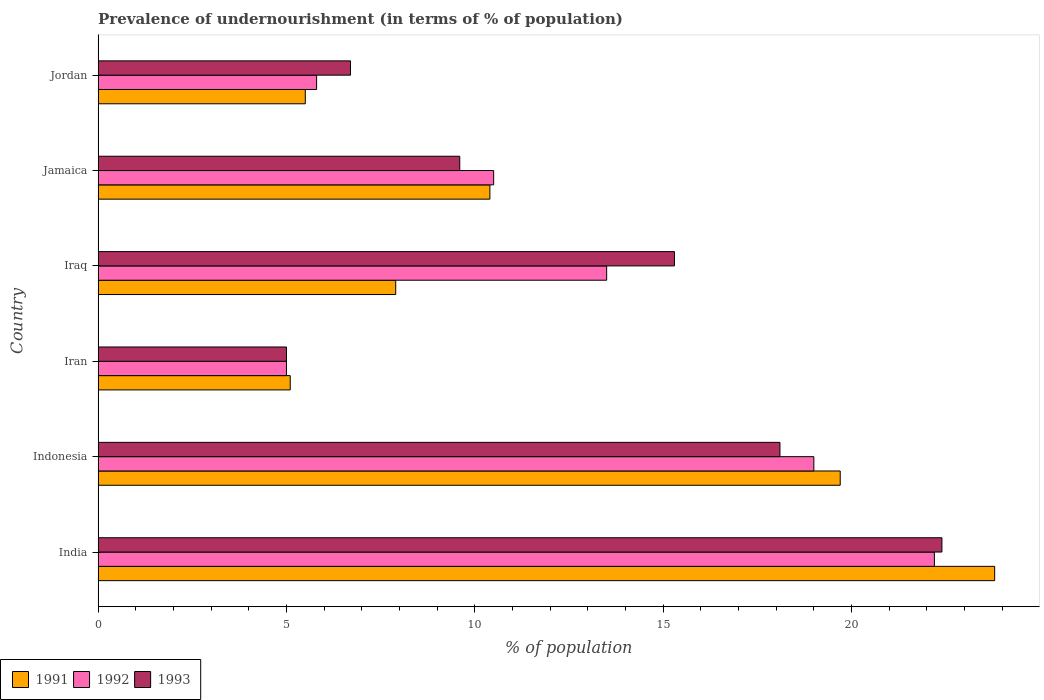How many different coloured bars are there?
Make the answer very short. 3. How many groups of bars are there?
Your response must be concise. 6. Are the number of bars per tick equal to the number of legend labels?
Your answer should be very brief. Yes. Are the number of bars on each tick of the Y-axis equal?
Make the answer very short. Yes. How many bars are there on the 6th tick from the top?
Your answer should be very brief. 3. How many bars are there on the 2nd tick from the bottom?
Provide a succinct answer. 3. What is the label of the 6th group of bars from the top?
Offer a terse response. India. In how many cases, is the number of bars for a given country not equal to the number of legend labels?
Your answer should be compact. 0. In which country was the percentage of undernourished population in 1993 maximum?
Your answer should be very brief. India. In which country was the percentage of undernourished population in 1993 minimum?
Make the answer very short. Iran. What is the total percentage of undernourished population in 1993 in the graph?
Offer a terse response. 77.1. What is the difference between the percentage of undernourished population in 1993 in Indonesia and that in Jamaica?
Provide a short and direct response. 8.5. What is the difference between the percentage of undernourished population in 1993 in Iraq and the percentage of undernourished population in 1991 in Iran?
Ensure brevity in your answer.  10.2. What is the average percentage of undernourished population in 1992 per country?
Your answer should be compact. 12.67. What is the difference between the percentage of undernourished population in 1991 and percentage of undernourished population in 1992 in Iraq?
Your answer should be compact. -5.6. What is the ratio of the percentage of undernourished population in 1993 in India to that in Iraq?
Your response must be concise. 1.46. What is the difference between the highest and the second highest percentage of undernourished population in 1991?
Your answer should be very brief. 4.1. What is the difference between the highest and the lowest percentage of undernourished population in 1991?
Give a very brief answer. 18.7. In how many countries, is the percentage of undernourished population in 1992 greater than the average percentage of undernourished population in 1992 taken over all countries?
Your answer should be compact. 3. What does the 1st bar from the top in India represents?
Your response must be concise. 1993. Are all the bars in the graph horizontal?
Offer a very short reply. Yes. How many countries are there in the graph?
Ensure brevity in your answer.  6. Are the values on the major ticks of X-axis written in scientific E-notation?
Give a very brief answer. No. Does the graph contain any zero values?
Make the answer very short. No. Where does the legend appear in the graph?
Offer a terse response. Bottom left. What is the title of the graph?
Keep it short and to the point. Prevalence of undernourishment (in terms of % of population). Does "2015" appear as one of the legend labels in the graph?
Provide a short and direct response. No. What is the label or title of the X-axis?
Ensure brevity in your answer.  % of population. What is the label or title of the Y-axis?
Keep it short and to the point. Country. What is the % of population in 1991 in India?
Provide a succinct answer. 23.8. What is the % of population in 1992 in India?
Make the answer very short. 22.2. What is the % of population of 1993 in India?
Make the answer very short. 22.4. What is the % of population of 1993 in Indonesia?
Offer a terse response. 18.1. What is the % of population of 1991 in Iraq?
Offer a terse response. 7.9. What is the % of population of 1992 in Iraq?
Offer a terse response. 13.5. What is the % of population of 1991 in Jamaica?
Ensure brevity in your answer.  10.4. What is the % of population of 1992 in Jamaica?
Provide a short and direct response. 10.5. What is the % of population in 1992 in Jordan?
Give a very brief answer. 5.8. What is the % of population of 1993 in Jordan?
Your answer should be very brief. 6.7. Across all countries, what is the maximum % of population in 1991?
Your answer should be compact. 23.8. Across all countries, what is the maximum % of population in 1993?
Your answer should be very brief. 22.4. Across all countries, what is the minimum % of population in 1991?
Provide a succinct answer. 5.1. What is the total % of population in 1991 in the graph?
Keep it short and to the point. 72.4. What is the total % of population in 1992 in the graph?
Your answer should be very brief. 76. What is the total % of population of 1993 in the graph?
Offer a terse response. 77.1. What is the difference between the % of population in 1991 in India and that in Indonesia?
Offer a very short reply. 4.1. What is the difference between the % of population of 1992 in India and that in Iran?
Keep it short and to the point. 17.2. What is the difference between the % of population of 1991 in Indonesia and that in Iraq?
Offer a terse response. 11.8. What is the difference between the % of population of 1992 in Indonesia and that in Iraq?
Give a very brief answer. 5.5. What is the difference between the % of population of 1992 in Indonesia and that in Jordan?
Make the answer very short. 13.2. What is the difference between the % of population of 1991 in Iran and that in Jordan?
Offer a very short reply. -0.4. What is the difference between the % of population in 1993 in Iran and that in Jordan?
Keep it short and to the point. -1.7. What is the difference between the % of population of 1991 in Iraq and that in Jamaica?
Your response must be concise. -2.5. What is the difference between the % of population of 1992 in Iraq and that in Jamaica?
Provide a succinct answer. 3. What is the difference between the % of population of 1993 in Iraq and that in Jamaica?
Your response must be concise. 5.7. What is the difference between the % of population in 1991 in Jamaica and that in Jordan?
Offer a very short reply. 4.9. What is the difference between the % of population of 1992 in Jamaica and that in Jordan?
Give a very brief answer. 4.7. What is the difference between the % of population in 1993 in Jamaica and that in Jordan?
Your answer should be compact. 2.9. What is the difference between the % of population in 1991 in India and the % of population in 1993 in Indonesia?
Keep it short and to the point. 5.7. What is the difference between the % of population in 1992 in India and the % of population in 1993 in Indonesia?
Keep it short and to the point. 4.1. What is the difference between the % of population of 1991 in India and the % of population of 1992 in Iran?
Make the answer very short. 18.8. What is the difference between the % of population of 1992 in India and the % of population of 1993 in Iran?
Offer a terse response. 17.2. What is the difference between the % of population in 1991 in India and the % of population in 1992 in Jamaica?
Your answer should be very brief. 13.3. What is the difference between the % of population in 1992 in India and the % of population in 1993 in Jamaica?
Provide a succinct answer. 12.6. What is the difference between the % of population of 1991 in India and the % of population of 1993 in Jordan?
Your response must be concise. 17.1. What is the difference between the % of population of 1992 in India and the % of population of 1993 in Jordan?
Your response must be concise. 15.5. What is the difference between the % of population in 1991 in Indonesia and the % of population in 1992 in Iran?
Keep it short and to the point. 14.7. What is the difference between the % of population in 1991 in Indonesia and the % of population in 1993 in Jamaica?
Your response must be concise. 10.1. What is the difference between the % of population of 1991 in Indonesia and the % of population of 1992 in Jordan?
Keep it short and to the point. 13.9. What is the difference between the % of population of 1991 in Indonesia and the % of population of 1993 in Jordan?
Offer a very short reply. 13. What is the difference between the % of population of 1991 in Iran and the % of population of 1992 in Jordan?
Your answer should be very brief. -0.7. What is the difference between the % of population of 1992 in Iran and the % of population of 1993 in Jordan?
Keep it short and to the point. -1.7. What is the difference between the % of population in 1991 in Iraq and the % of population in 1992 in Jamaica?
Offer a terse response. -2.6. What is the difference between the % of population in 1992 in Iraq and the % of population in 1993 in Jordan?
Provide a short and direct response. 6.8. What is the difference between the % of population of 1991 in Jamaica and the % of population of 1992 in Jordan?
Offer a terse response. 4.6. What is the difference between the % of population in 1992 in Jamaica and the % of population in 1993 in Jordan?
Give a very brief answer. 3.8. What is the average % of population in 1991 per country?
Give a very brief answer. 12.07. What is the average % of population in 1992 per country?
Your response must be concise. 12.67. What is the average % of population of 1993 per country?
Offer a very short reply. 12.85. What is the difference between the % of population in 1991 and % of population in 1992 in India?
Make the answer very short. 1.6. What is the difference between the % of population of 1992 and % of population of 1993 in India?
Your response must be concise. -0.2. What is the difference between the % of population in 1991 and % of population in 1992 in Indonesia?
Ensure brevity in your answer.  0.7. What is the difference between the % of population in 1992 and % of population in 1993 in Indonesia?
Your answer should be compact. 0.9. What is the difference between the % of population of 1991 and % of population of 1992 in Iran?
Provide a succinct answer. 0.1. What is the difference between the % of population in 1992 and % of population in 1993 in Iran?
Offer a terse response. 0. What is the difference between the % of population of 1992 and % of population of 1993 in Iraq?
Keep it short and to the point. -1.8. What is the difference between the % of population in 1991 and % of population in 1993 in Jamaica?
Your answer should be compact. 0.8. What is the difference between the % of population in 1991 and % of population in 1992 in Jordan?
Provide a succinct answer. -0.3. What is the difference between the % of population in 1991 and % of population in 1993 in Jordan?
Ensure brevity in your answer.  -1.2. What is the difference between the % of population of 1992 and % of population of 1993 in Jordan?
Offer a very short reply. -0.9. What is the ratio of the % of population in 1991 in India to that in Indonesia?
Your response must be concise. 1.21. What is the ratio of the % of population in 1992 in India to that in Indonesia?
Provide a succinct answer. 1.17. What is the ratio of the % of population in 1993 in India to that in Indonesia?
Provide a succinct answer. 1.24. What is the ratio of the % of population of 1991 in India to that in Iran?
Your answer should be compact. 4.67. What is the ratio of the % of population of 1992 in India to that in Iran?
Provide a succinct answer. 4.44. What is the ratio of the % of population of 1993 in India to that in Iran?
Provide a succinct answer. 4.48. What is the ratio of the % of population of 1991 in India to that in Iraq?
Make the answer very short. 3.01. What is the ratio of the % of population of 1992 in India to that in Iraq?
Make the answer very short. 1.64. What is the ratio of the % of population in 1993 in India to that in Iraq?
Keep it short and to the point. 1.46. What is the ratio of the % of population of 1991 in India to that in Jamaica?
Provide a succinct answer. 2.29. What is the ratio of the % of population of 1992 in India to that in Jamaica?
Offer a very short reply. 2.11. What is the ratio of the % of population in 1993 in India to that in Jamaica?
Offer a very short reply. 2.33. What is the ratio of the % of population of 1991 in India to that in Jordan?
Make the answer very short. 4.33. What is the ratio of the % of population of 1992 in India to that in Jordan?
Give a very brief answer. 3.83. What is the ratio of the % of population in 1993 in India to that in Jordan?
Make the answer very short. 3.34. What is the ratio of the % of population of 1991 in Indonesia to that in Iran?
Ensure brevity in your answer.  3.86. What is the ratio of the % of population of 1993 in Indonesia to that in Iran?
Make the answer very short. 3.62. What is the ratio of the % of population of 1991 in Indonesia to that in Iraq?
Your answer should be very brief. 2.49. What is the ratio of the % of population of 1992 in Indonesia to that in Iraq?
Ensure brevity in your answer.  1.41. What is the ratio of the % of population in 1993 in Indonesia to that in Iraq?
Offer a very short reply. 1.18. What is the ratio of the % of population in 1991 in Indonesia to that in Jamaica?
Offer a very short reply. 1.89. What is the ratio of the % of population of 1992 in Indonesia to that in Jamaica?
Ensure brevity in your answer.  1.81. What is the ratio of the % of population in 1993 in Indonesia to that in Jamaica?
Offer a terse response. 1.89. What is the ratio of the % of population of 1991 in Indonesia to that in Jordan?
Your response must be concise. 3.58. What is the ratio of the % of population of 1992 in Indonesia to that in Jordan?
Your answer should be compact. 3.28. What is the ratio of the % of population in 1993 in Indonesia to that in Jordan?
Offer a terse response. 2.7. What is the ratio of the % of population in 1991 in Iran to that in Iraq?
Your response must be concise. 0.65. What is the ratio of the % of population of 1992 in Iran to that in Iraq?
Offer a very short reply. 0.37. What is the ratio of the % of population in 1993 in Iran to that in Iraq?
Provide a succinct answer. 0.33. What is the ratio of the % of population in 1991 in Iran to that in Jamaica?
Provide a succinct answer. 0.49. What is the ratio of the % of population of 1992 in Iran to that in Jamaica?
Ensure brevity in your answer.  0.48. What is the ratio of the % of population of 1993 in Iran to that in Jamaica?
Provide a short and direct response. 0.52. What is the ratio of the % of population in 1991 in Iran to that in Jordan?
Your answer should be very brief. 0.93. What is the ratio of the % of population in 1992 in Iran to that in Jordan?
Give a very brief answer. 0.86. What is the ratio of the % of population of 1993 in Iran to that in Jordan?
Offer a terse response. 0.75. What is the ratio of the % of population in 1991 in Iraq to that in Jamaica?
Offer a very short reply. 0.76. What is the ratio of the % of population in 1992 in Iraq to that in Jamaica?
Keep it short and to the point. 1.29. What is the ratio of the % of population of 1993 in Iraq to that in Jamaica?
Your response must be concise. 1.59. What is the ratio of the % of population in 1991 in Iraq to that in Jordan?
Ensure brevity in your answer.  1.44. What is the ratio of the % of population in 1992 in Iraq to that in Jordan?
Your answer should be very brief. 2.33. What is the ratio of the % of population of 1993 in Iraq to that in Jordan?
Your response must be concise. 2.28. What is the ratio of the % of population in 1991 in Jamaica to that in Jordan?
Provide a short and direct response. 1.89. What is the ratio of the % of population of 1992 in Jamaica to that in Jordan?
Give a very brief answer. 1.81. What is the ratio of the % of population in 1993 in Jamaica to that in Jordan?
Give a very brief answer. 1.43. What is the difference between the highest and the second highest % of population in 1993?
Give a very brief answer. 4.3. What is the difference between the highest and the lowest % of population of 1992?
Provide a short and direct response. 17.2. 